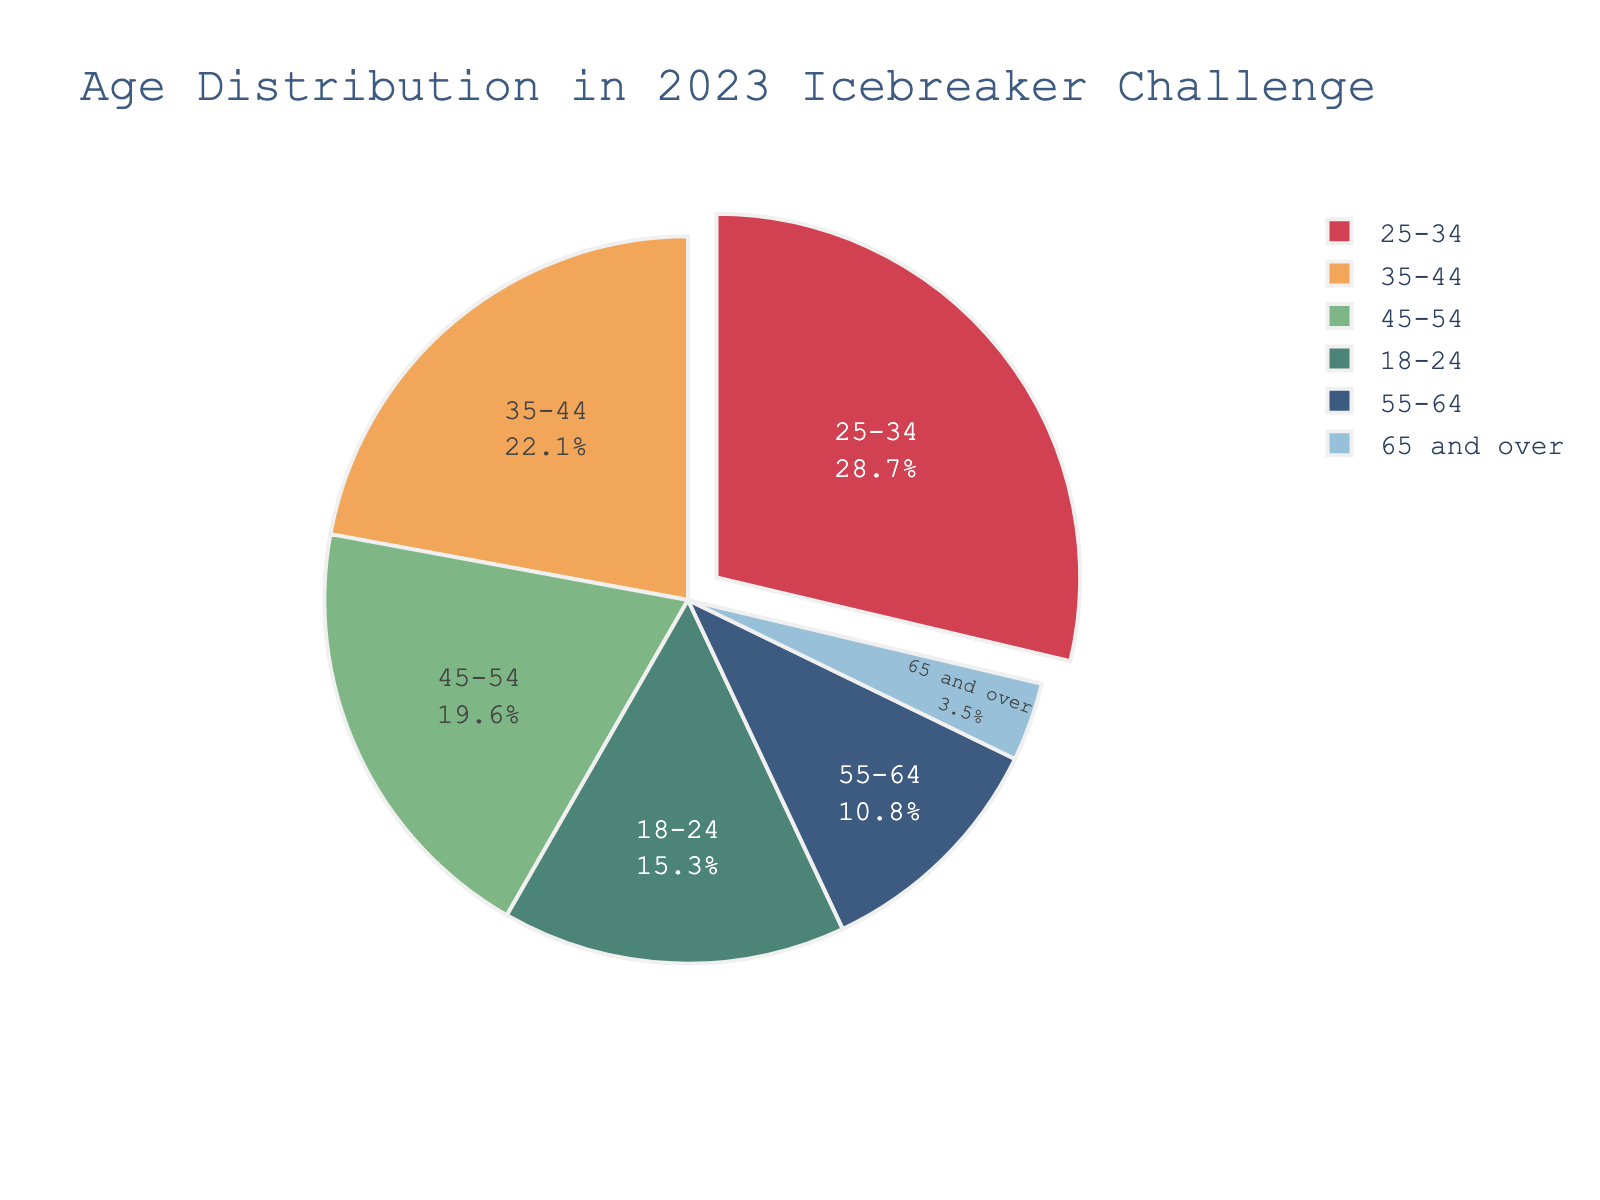What age group has the highest percentage of participants? The segment with the largest proportion in the pie chart is highlighted. The 25-34 age group has the largest segment.
Answer: 25-34 Which age group has the smallest percentage of participants? The segment with the smallest proportion in the pie chart can be observed. The 65 and over group has the smallest segment.
Answer: 65 and over How much larger is the percentage of participants in the 25-34 age group compared to the 55-64 age group? The percentage of the 25-34 group is 28.7%, and the 55-64 group is 10.8%. The difference is 28.7 - 10.8.
Answer: 17.9% What is the sum of the percentages of participants in the 18-24 and 35-44 age groups? The percentage of the 18-24 group is 15.3%, and the 35-44 group is 22.1%. The sum is 15.3 + 22.1.
Answer: 37.4% Which age group appears in green color on the pie chart? By observing the pie chart, the green color segment represents the 35-44 age group.
Answer: 35-44 How much larger is the combined percentage of participants aged 25-34 and 35-44 compared to those aged 45-54 and 55-64? The combined percentage of 25-34 and 35-44 is 28.7 + 22.1 = 50.8%. The combined percentage of 45-54 and 55-64 is 19.6 + 10.8 = 30.4%. The difference is 50.8 - 30.4.
Answer: 20.4% Which age groups together make up more than half of the total participants? Considering the percentages, the age groups 25-34 (28.7%) and 35-44 (22.1%) together make up 28.7 + 22.1 = 50.8%, which is more than half of the total.
Answer: 25-34 and 35-44 What is the median age group in terms of participation percentages? Listing the percentages: 3.5%, 10.8%, 15.3%, 19.6%, 22.1%, 28.7%. The median falls between 15.3% and 19.6%. (15.3+19.6)/2 = 17.45%. So it’s the 18-24 and 45-54 age groups.
Answer: 18-24 and 45-54 